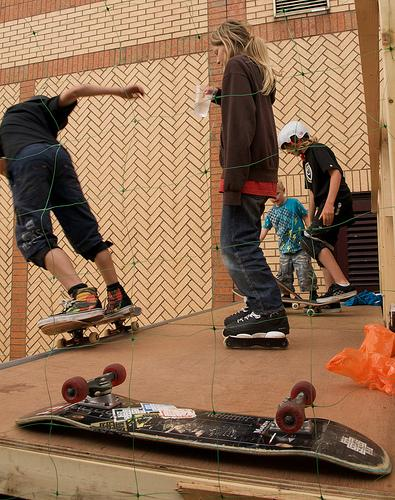Identify the objects on the ground and their colors. There's an orange paper or plastic bag and an upside-down skateboard with red wheels on the ground. Provide a brief description of the skateboard and its position in the image. The skateboard is lying upside down with red wheels and is positioned near the edge of a ramp. Provide some details about the architectural features in the image. There is a white vent for a heating/air system and a brick wall in a herringbone design on the side of the building. List the various colors of shirts mentioned in the image and who is wearing them. There's a brown jacket, a black shirt, a blue shirt worn by a small boy, and a red shirt underneath a brown sweatshirt. How would you describe the overall sentiment or mood of the image? The image depicts a lively and energetic atmosphere, with individuals engaged in various outdoor activities such as skateboarding and inline skating. Describe the type of shoes worn by the individuals in the image and their colors. One individual is wearing black and white inline skates, while another has black and white checkered shoes. What kind of tricks or activities are being performed by the people in the image? A boy is riding a skateboard, flipping it, or attempting a trick, while another person is wearing inline skates and holding a glass of water. Mention the types of headwear present in the image and their colors. There is a white safety helmet worn by a boy and a blonde ponytail on a child. What is the girl holding in her hand and provide some details about it? The girl is holding a clear plastic cup filled with water. What kind of skates is the girl wearing and what color are they? The girl is wearing black inline skates with white wheels. Is the scene in the image positive or negative? Explain briefly. Positive; it shows young people engaging in fun, active outdoor activities. What is the main activity of the boy in the image? Riding on a skateboard Is the girl wearing a helmet? No, she is not wearing a helmet. Choose the correct statement: The girl's skates are (a) white and black, (b) red and white, (c) black and white. (c) black and white Is the boy wearing red sneakers? The sneakers are actually black, not red. What is the color of the skate wheels? Red Identify the color of the paper-like object on the ground. Orange List any text or numbers visible in the image. No text or numbers are visible in the image. Is there any interaction between the skateboard and the orange plastic on the ground? No, they are separate objects with no direct interaction. Describe the image in a simple sentence. A boy is performing a skateboard trick while a girl in skates watches. What color is the boy's shirt? Blue Who is holding a glass of water? The girl in inline skates Identify any unusual objects or anomalies in the image. There are no significant anomalies present in the image. Describe the attributes of the girl's inline skates. Black skates with white wheels Are the skateboard wheels blue? The skateboard wheels are red, not blue. What kind of shoes is the girl wearing? Inline skates Enumerate the objects in the image. Boy, skateboard, girl, inline skates, white helmet, orange plastic, water cup, blue jeans, red wheels, vent. Is the girl wearing pink inline skates? The inline skates are actually black, not pink. Is there a purple plastic bag on the ground? The plastic on the ground is orange, not purple. Rate the image quality on a scale of 1 to 10. 8 What kind of wall is behind the kids? Brick wall Does the boy have a green helmet on? The helmet is actually white, not green. Is the brick wall in a diagonal design? The brick wall is actually in a herringbone design, not diagonal. What is the position of the skateboard in relation to the ramp? At the edge of the ramp What is the layout of the bricks on the wall? Herringbone design 